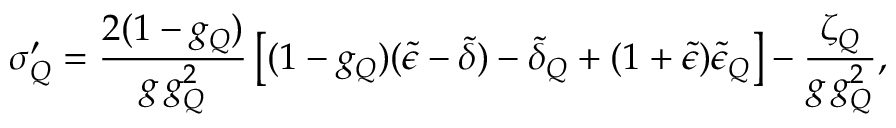Convert formula to latex. <formula><loc_0><loc_0><loc_500><loc_500>\sigma _ { Q } ^ { \prime } = \frac { 2 ( 1 - g _ { Q } ) } { g \, g _ { Q } ^ { 2 } } \left [ ( 1 - g _ { Q } ) ( \tilde { \epsilon } - \tilde { \delta } ) - \tilde { \delta } _ { Q } + ( 1 + \tilde { \epsilon } ) \tilde { \epsilon } _ { Q } \right ] - \frac { \zeta _ { Q } } { g \, g _ { Q } ^ { 2 } } ,</formula> 